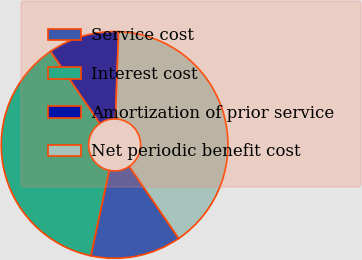Convert chart to OTSL. <chart><loc_0><loc_0><loc_500><loc_500><pie_chart><fcel>Service cost<fcel>Interest cost<fcel>Amortization of prior service<fcel>Net periodic benefit cost<nl><fcel>12.92%<fcel>37.08%<fcel>10.11%<fcel>39.89%<nl></chart> 